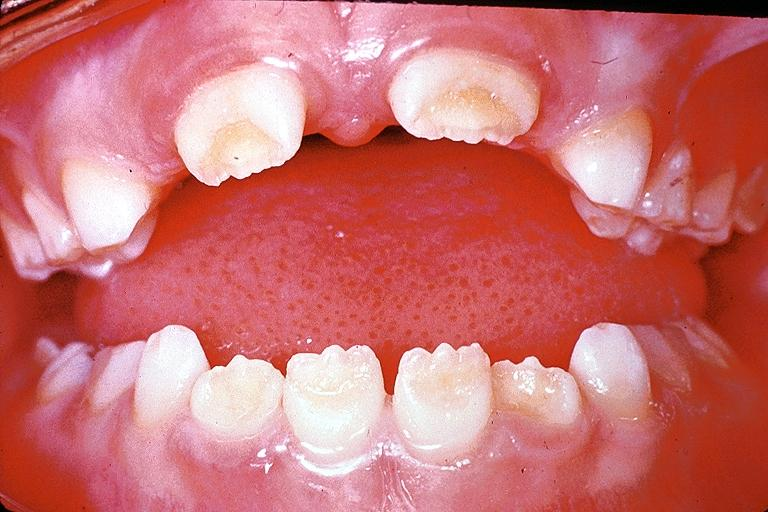s thyroid present?
Answer the question using a single word or phrase. No 